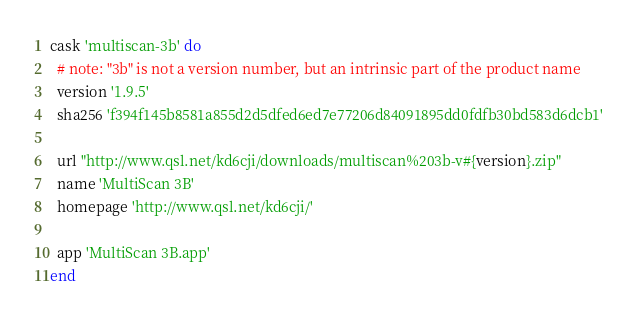Convert code to text. <code><loc_0><loc_0><loc_500><loc_500><_Ruby_>cask 'multiscan-3b' do
  # note: "3b" is not a version number, but an intrinsic part of the product name
  version '1.9.5'
  sha256 'f394f145b8581a855d2d5dfed6ed7e77206d84091895dd0fdfb30bd583d6dcb1'

  url "http://www.qsl.net/kd6cji/downloads/multiscan%203b-v#{version}.zip"
  name 'MultiScan 3B'
  homepage 'http://www.qsl.net/kd6cji/'

  app 'MultiScan 3B.app'
end
</code> 